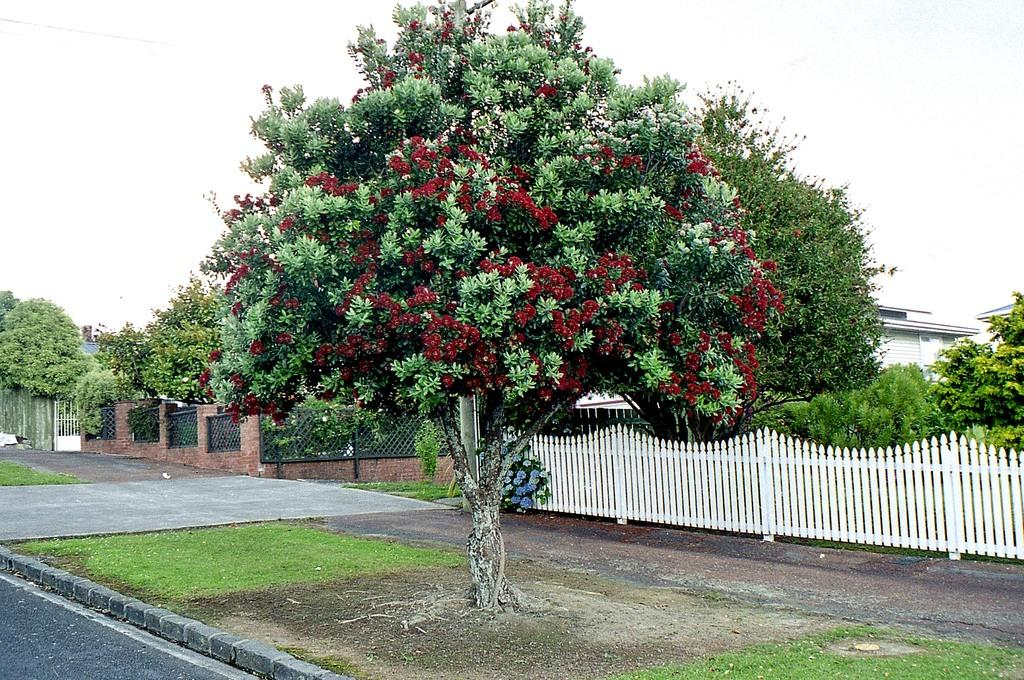What type of vegetation can be seen in the image? There is a tree, grass, and a plant with flowers in the image. What type of barrier is present in the image? There is a fence in the image. What can be seen in the background of the image? In the background, there is a fence, trees, a wall, a house, and the sky. What language is the plant with flowers speaking in the image? Plants do not speak languages, so this question cannot be answered. --- Facts: 1. There is a car in the image. 2. The car is red. 3. The car has four wheels. 4. There is a person standing next to the car. 5. The person is holding a key. Absurd Topics: dance, ocean, bird Conversation: What type of vehicle is in the image? There is a car in the image. What color is the car? The car is red. How many wheels does the car have? The car has four wheels. What is the person next to the car doing? The person is holding a key. Reasoning: Let's think step by step in order to produce the conversation. We start by identifying the main subject in the image, which is the car. Then, we describe the car's color and the number of wheels it has. Finally, we expand the conversation to include the person standing next to the car and the action they are performing, which is holding a key. Absurd Question/Answer: Can you see any birds dancing in the ocean near the car? There is no ocean or birds present in the image, so this question cannot be answered. 